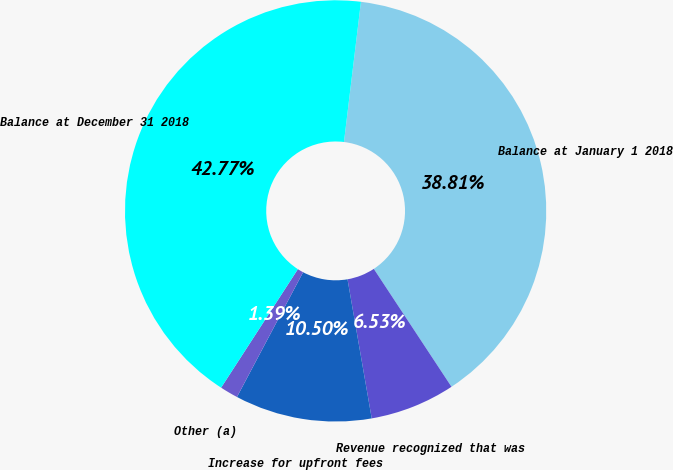Convert chart to OTSL. <chart><loc_0><loc_0><loc_500><loc_500><pie_chart><fcel>Balance at January 1 2018<fcel>Revenue recognized that was<fcel>Increase for upfront fees<fcel>Other (a)<fcel>Balance at December 31 2018<nl><fcel>38.81%<fcel>6.53%<fcel>10.5%<fcel>1.39%<fcel>42.77%<nl></chart> 